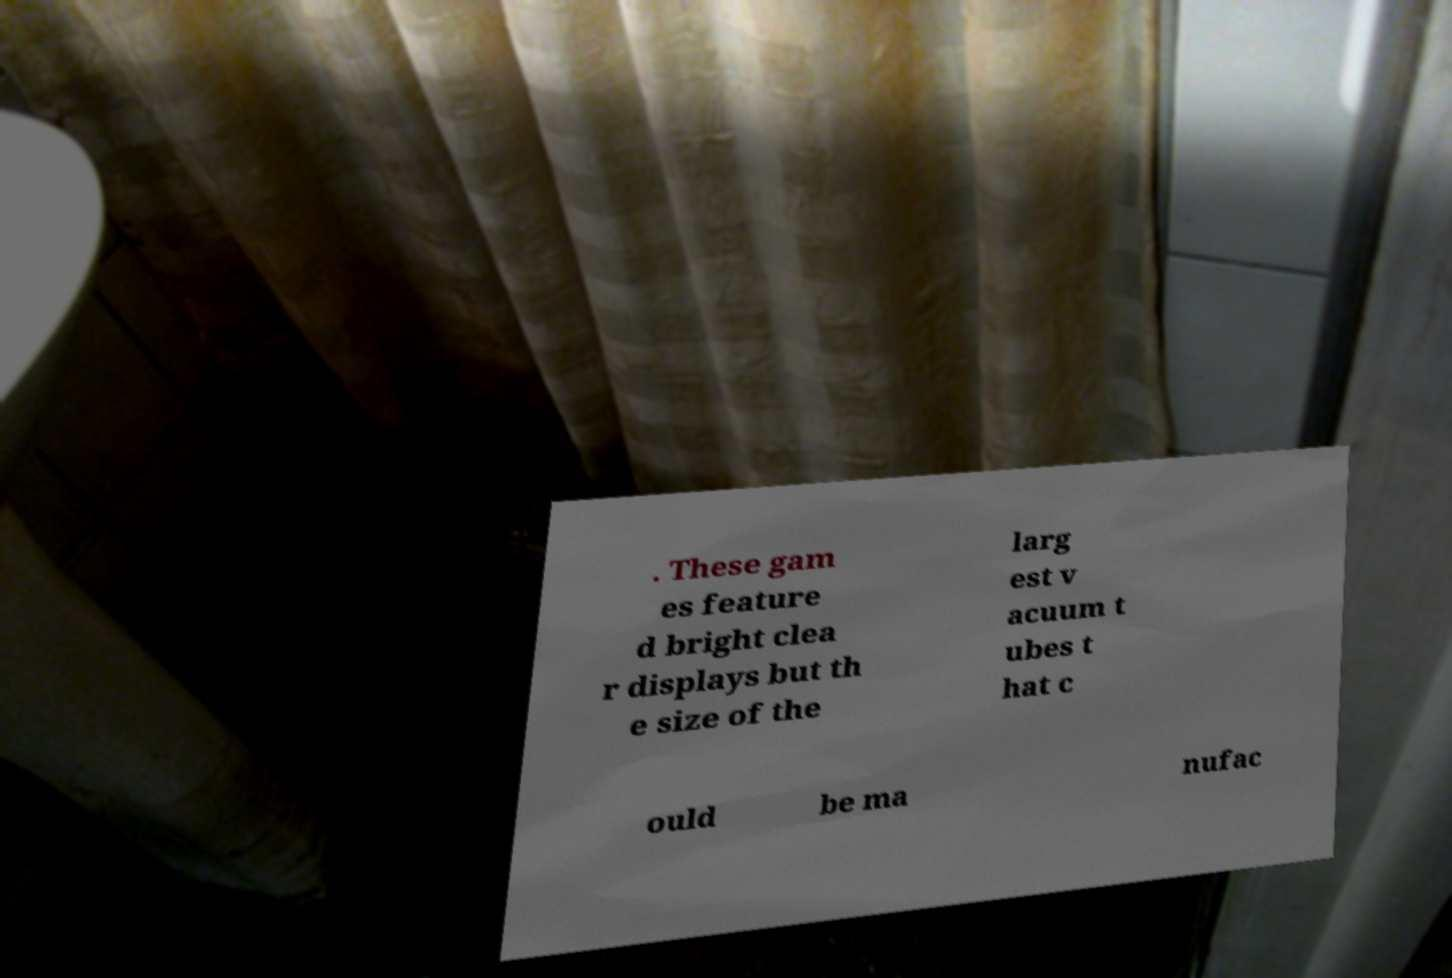Can you accurately transcribe the text from the provided image for me? . These gam es feature d bright clea r displays but th e size of the larg est v acuum t ubes t hat c ould be ma nufac 